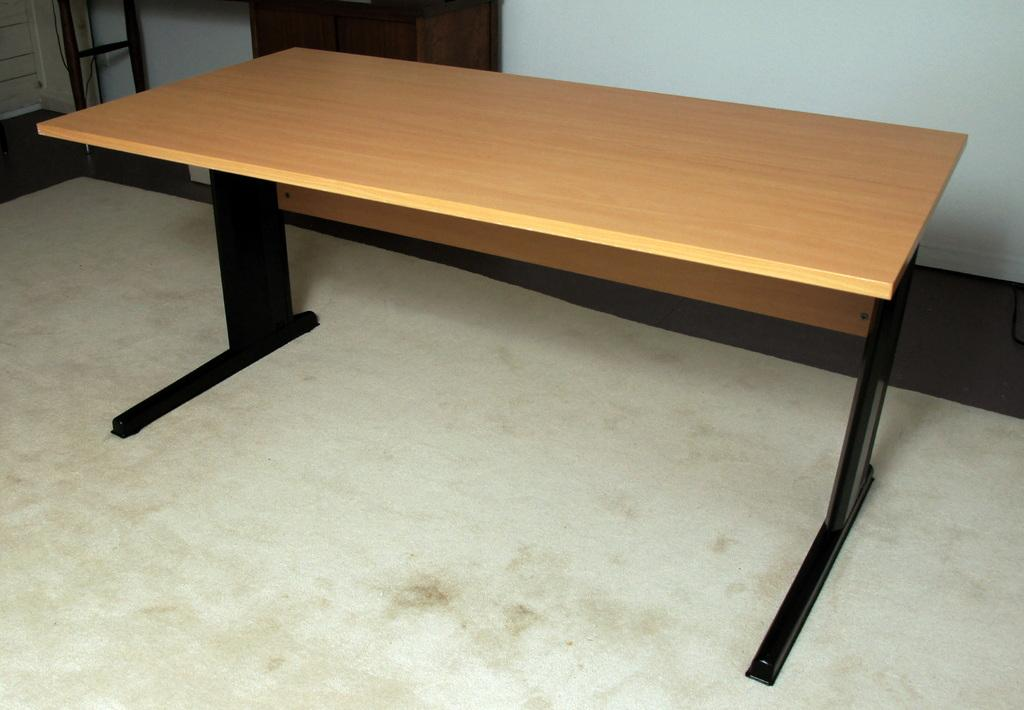What is the main object in the center of the image? There is a table in the center of the image. What can be seen in the background of the image? There is a stand and a wall in the background of the image. What is the surface on which the table and other objects are placed? There is a floor at the bottom of the image. Can you describe the waves crashing against the wall in the image? There are no waves present in the image; it features a table, a stand, and a wall in the background. 